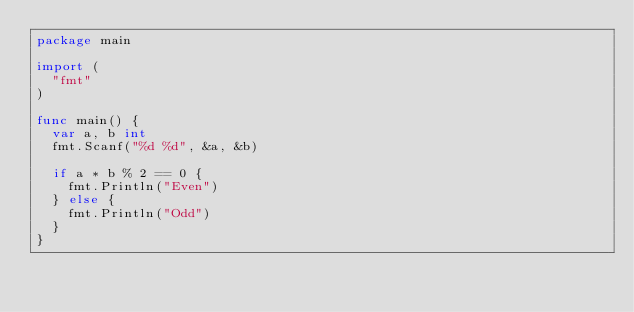Convert code to text. <code><loc_0><loc_0><loc_500><loc_500><_Go_>package main

import (
	"fmt"
)

func main() {
	var a, b int
	fmt.Scanf("%d %d", &a, &b)

	if a * b % 2 == 0 {
		fmt.Println("Even")
	} else {
		fmt.Println("Odd")
	}
}</code> 